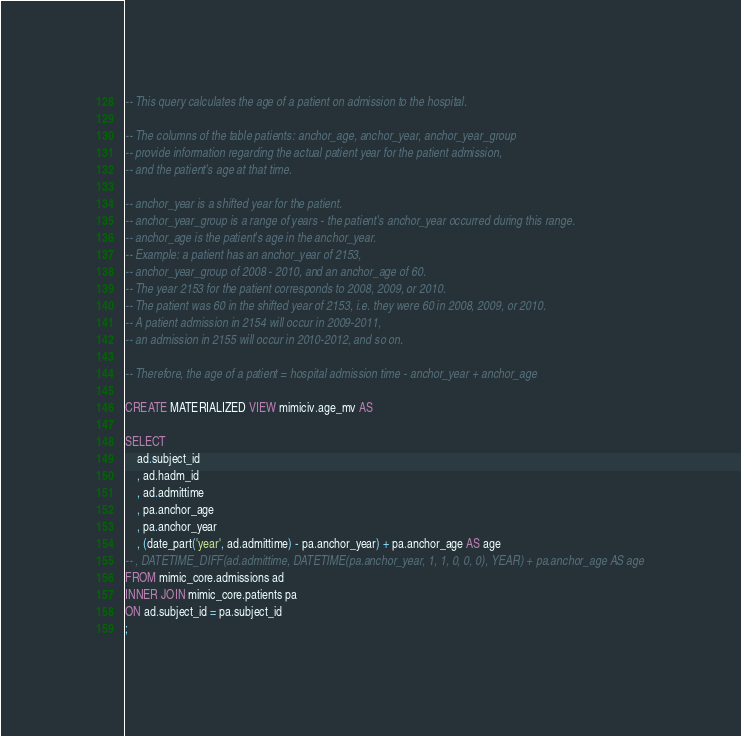Convert code to text. <code><loc_0><loc_0><loc_500><loc_500><_SQL_>-- This query calculates the age of a patient on admission to the hospital.

-- The columns of the table patients: anchor_age, anchor_year, anchor_year_group
-- provide information regarding the actual patient year for the patient admission, 
-- and the patient's age at that time.

-- anchor_year is a shifted year for the patient.
-- anchor_year_group is a range of years - the patient's anchor_year occurred during this range.
-- anchor_age is the patient's age in the anchor_year.
-- Example: a patient has an anchor_year of 2153,
-- anchor_year_group of 2008 - 2010, and an anchor_age of 60.
-- The year 2153 for the patient corresponds to 2008, 2009, or 2010.
-- The patient was 60 in the shifted year of 2153, i.e. they were 60 in 2008, 2009, or 2010.
-- A patient admission in 2154 will occur in 2009-2011, 
-- an admission in 2155 will occur in 2010-2012, and so on.

-- Therefore, the age of a patient = hospital admission time - anchor_year + anchor_age

CREATE MATERIALIZED VIEW mimiciv.age_mv AS

SELECT 	
	ad.subject_id
	, ad.hadm_id
	, ad.admittime
	, pa.anchor_age
	, pa.anchor_year
	, (date_part('year', ad.admittime) - pa.anchor_year) + pa.anchor_age AS age
-- , DATETIME_DIFF(ad.admittime, DATETIME(pa.anchor_year, 1, 1, 0, 0, 0), YEAR) + pa.anchor_age AS age
FROM mimic_core.admissions ad
INNER JOIN mimic_core.patients pa
ON ad.subject_id = pa.subject_id
;</code> 